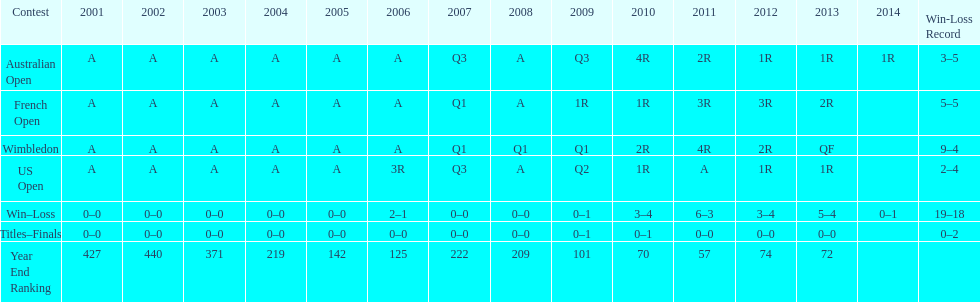In which years was a rating under 200 accomplished? 2005, 2006, 2009, 2010, 2011, 2012, 2013. 